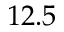Convert formula to latex. <formula><loc_0><loc_0><loc_500><loc_500>1 2 . 5</formula> 